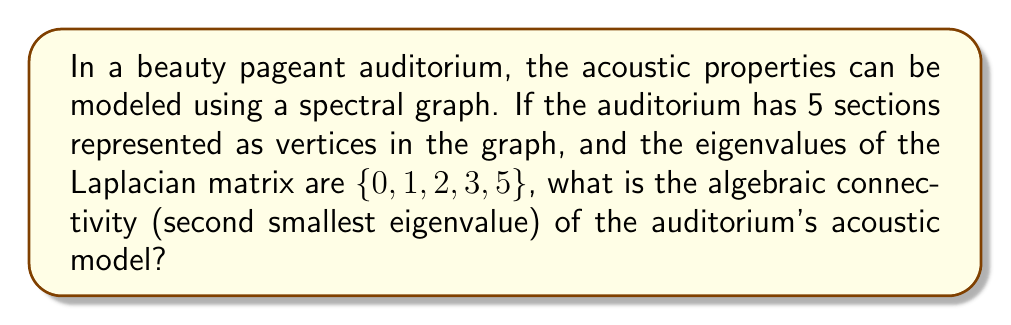Give your solution to this math problem. To solve this problem, let's break it down step-by-step:

1) In spectral graph theory, the acoustic properties of a space can be represented by a graph, where vertices represent different sections of the auditorium.

2) The Laplacian matrix is used to describe the graph's structure and connectivity. Its eigenvalues provide important information about the graph's properties.

3) The eigenvalues of the Laplacian matrix are given as $\{0, 1, 2, 3, 5\}$.

4) In spectral graph theory, the eigenvalues are typically arranged in ascending order:

   $$0 = \lambda_1 \leq \lambda_2 \leq \lambda_3 \leq \lambda_4 \leq \lambda_5$$

5) The algebraic connectivity is defined as the second smallest eigenvalue of the Laplacian matrix.

6) Looking at our ordered set of eigenvalues $\{0, 1, 2, 3, 5\}$, we can identify:
   - $\lambda_1 = 0$ (the smallest eigenvalue, always 0 for connected graphs)
   - $\lambda_2 = 1$ (the second smallest eigenvalue)

7) Therefore, the algebraic connectivity of the auditorium's acoustic model is 1.

This value indicates how well-connected the auditorium's sections are acoustically. A higher value would suggest better overall acoustic connectivity, which is important for clear sound transmission during pageant speeches.
Answer: 1 